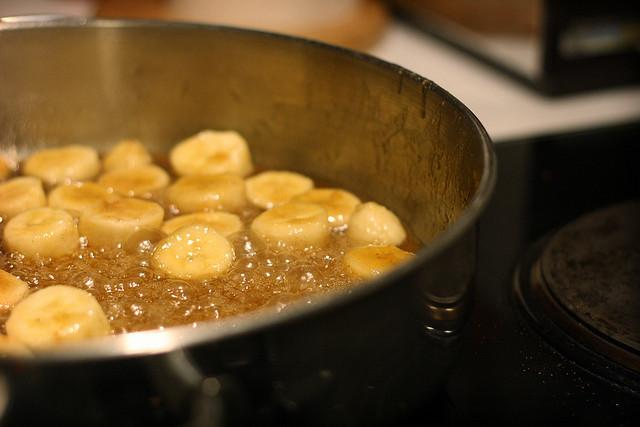What is this pan currently being used to create? fried bananas 